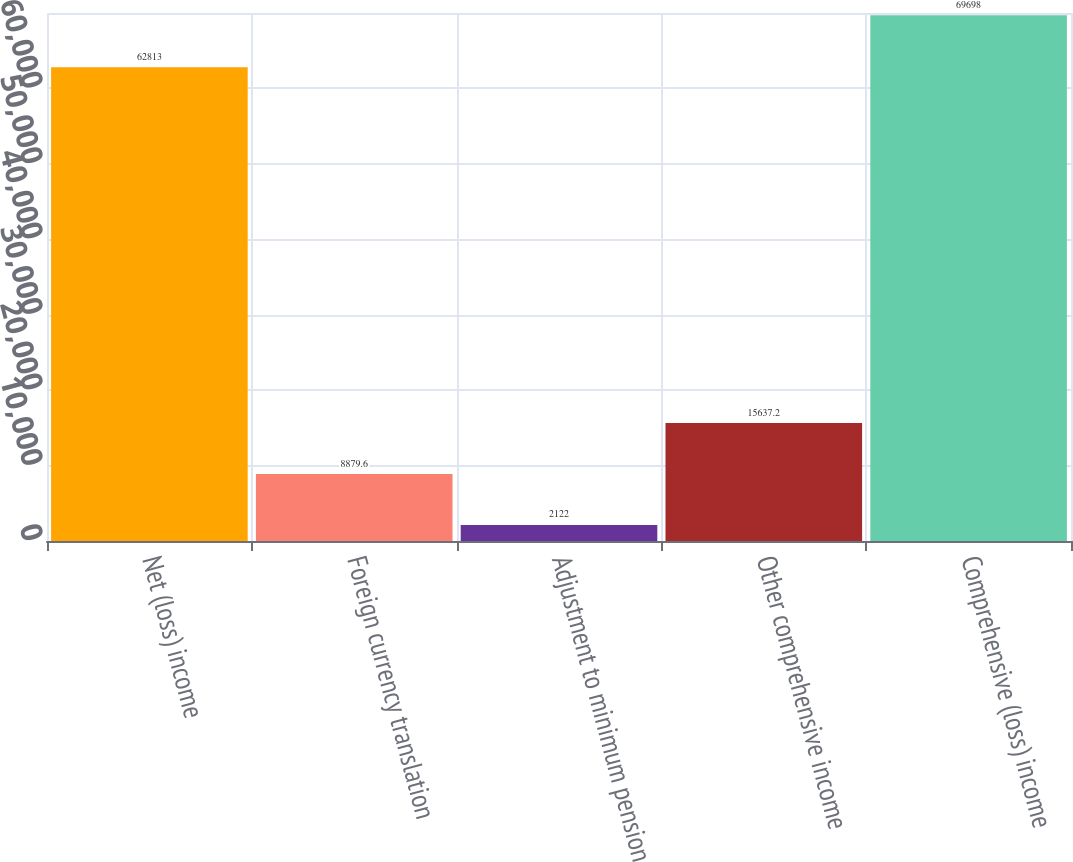Convert chart to OTSL. <chart><loc_0><loc_0><loc_500><loc_500><bar_chart><fcel>Net (loss) income<fcel>Foreign currency translation<fcel>Adjustment to minimum pension<fcel>Other comprehensive income<fcel>Comprehensive (loss) income<nl><fcel>62813<fcel>8879.6<fcel>2122<fcel>15637.2<fcel>69698<nl></chart> 